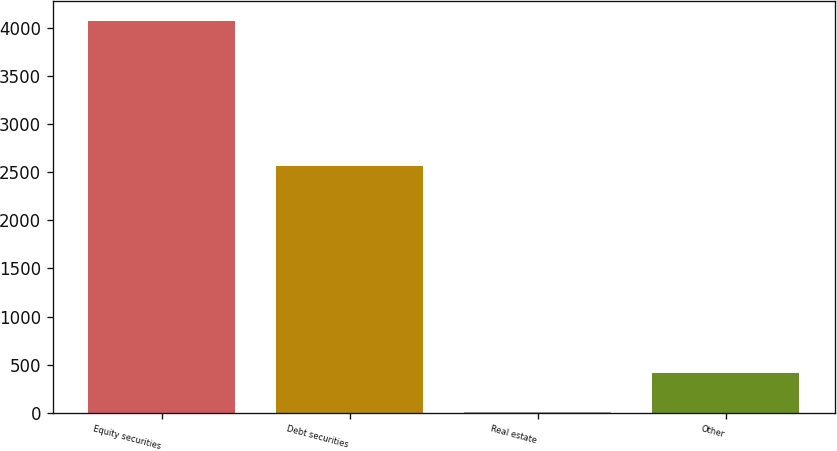<chart> <loc_0><loc_0><loc_500><loc_500><bar_chart><fcel>Equity securities<fcel>Debt securities<fcel>Real estate<fcel>Other<nl><fcel>4075<fcel>2560<fcel>10<fcel>416.5<nl></chart> 